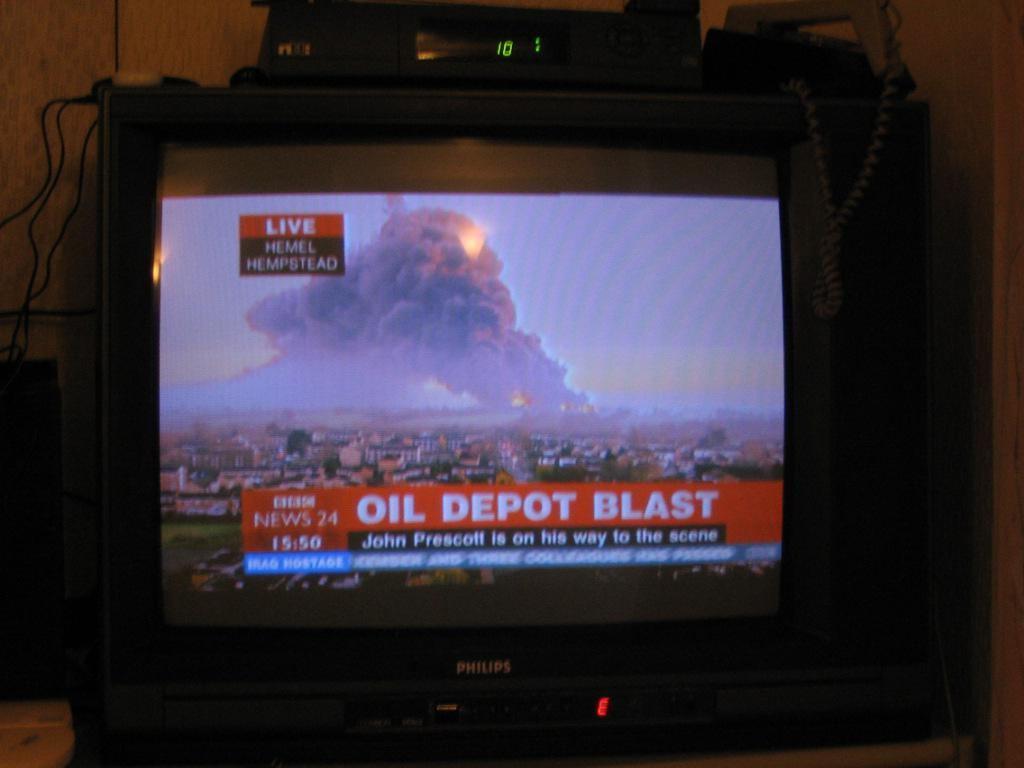Provide a one-sentence caption for the provided image. Television news screen that is live from Hemel Hempstead that says Oil Depot Blast. 